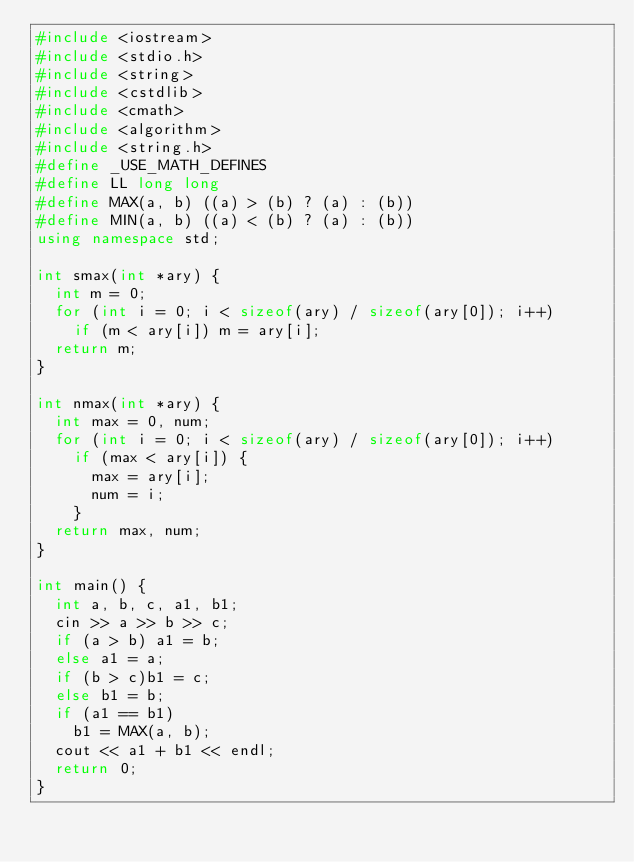Convert code to text. <code><loc_0><loc_0><loc_500><loc_500><_C++_>#include <iostream>
#include <stdio.h>
#include <string>
#include <cstdlib>
#include <cmath>
#include <algorithm>
#include <string.h>
#define _USE_MATH_DEFINES
#define LL long long
#define MAX(a, b) ((a) > (b) ? (a) : (b))
#define MIN(a, b) ((a) < (b) ? (a) : (b))
using namespace std;

int smax(int *ary) {
	int m = 0;
	for (int i = 0; i < sizeof(ary) / sizeof(ary[0]); i++)
		if (m < ary[i]) m = ary[i];
	return m;
}

int nmax(int *ary) {
	int max = 0, num;
	for (int i = 0; i < sizeof(ary) / sizeof(ary[0]); i++)
		if (max < ary[i]) {
			max = ary[i];
			num = i;
		}
	return max, num;
}

int main() {
	int a, b, c, a1, b1;
	cin >> a >> b >> c;
	if (a > b) a1 = b;
	else a1 = a;
	if (b > c)b1 = c;
	else b1 = b;
	if (a1 == b1)
		b1 = MAX(a, b);
	cout << a1 + b1 << endl;
	return 0;
}

</code> 